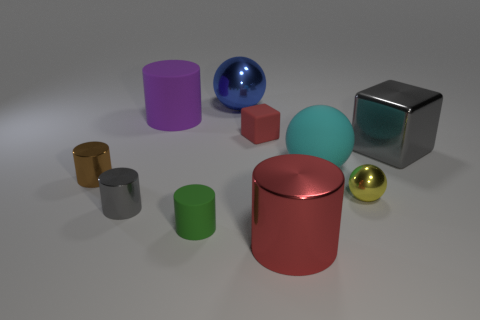How many objects have the same size as the red metal cylinder?
Provide a short and direct response. 4. There is a large sphere that is made of the same material as the tiny ball; what is its color?
Offer a very short reply. Blue. Is the number of red matte cubes less than the number of large purple metallic cylinders?
Offer a terse response. No. What number of cyan objects are either big matte things or large metal cylinders?
Give a very brief answer. 1. What number of blocks are to the right of the tiny yellow metal sphere and to the left of the large red thing?
Offer a terse response. 0. Is the material of the small red object the same as the gray cube?
Keep it short and to the point. No. What shape is the green matte thing that is the same size as the brown metal object?
Keep it short and to the point. Cylinder. Is the number of red shiny cylinders greater than the number of metal balls?
Ensure brevity in your answer.  No. What is the material of the ball that is both right of the large blue metallic thing and on the left side of the yellow thing?
Offer a terse response. Rubber. How many other things are made of the same material as the big cyan sphere?
Provide a succinct answer. 3. 